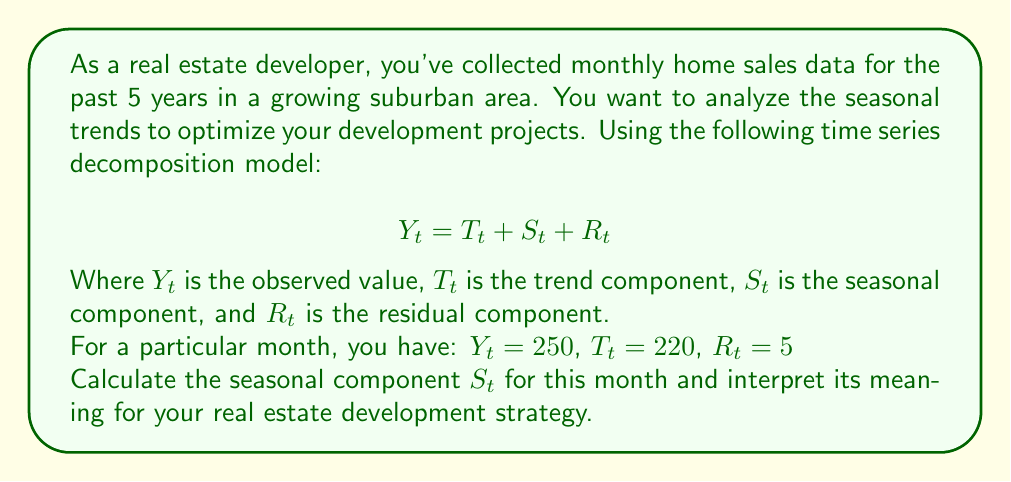Can you solve this math problem? To solve this problem, we'll use the time series decomposition model provided:

$$ Y_t = T_t + S_t + R_t $$

We're given the following values:
$Y_t = 250$ (observed value)
$T_t = 220$ (trend component)
$R_t = 5$ (residual component)

To find the seasonal component $S_t$, we need to rearrange the equation:

$$ S_t = Y_t - T_t - R_t $$

Now, let's substitute the known values:

$$ S_t = 250 - 220 - 5 $$

$$ S_t = 25 $$

Interpretation:
The seasonal component $S_t = 25$ indicates that for this particular month, there is a positive seasonal effect of 25 units (e.g., 25 additional home sales) compared to the overall trend. This suggests that this month typically experiences higher demand than the average.

For your real estate development strategy, this information is valuable because:

1. Timing: You may want to ensure that new properties are ready for sale during this month to capitalize on the increased demand.
2. Pricing: You could potentially set slightly higher prices during this period due to the increased demand.
3. Marketing: Allocate more marketing resources to this month to maximize exposure during the high-demand period.
4. Cash flow: Plan for increased cash inflows during this month, which could help with financing other projects or investments.
5. Supply chain: Ensure that your supply chain and construction timelines align with this seasonal peak to meet the higher demand.

By understanding these seasonal patterns, you can optimize your development projects, marketing efforts, and financial planning to maximize returns and minimize risks associated with seasonal fluctuations in the real estate market.
Answer: $S_t = 25$ 